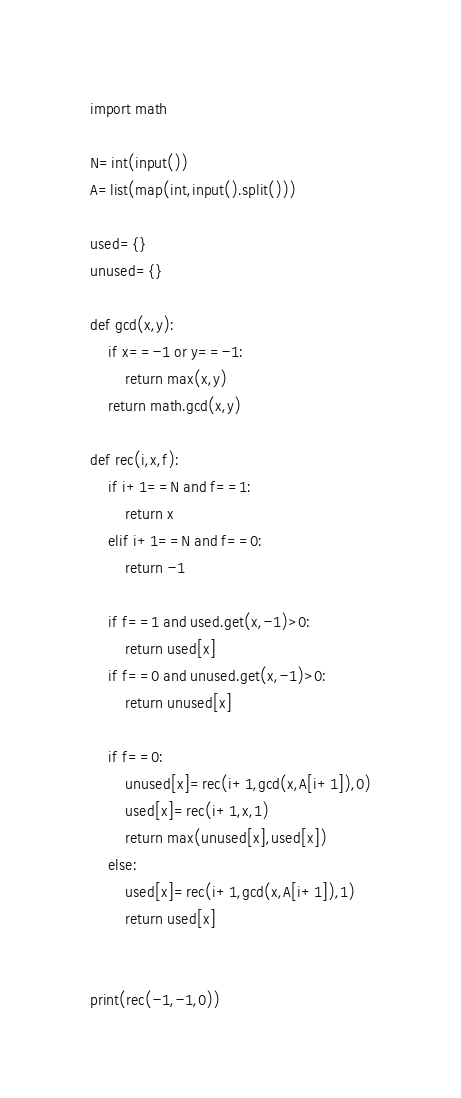<code> <loc_0><loc_0><loc_500><loc_500><_Python_>import math

N=int(input())
A=list(map(int,input().split()))

used={}
unused={}

def gcd(x,y):
    if x==-1 or y==-1:
        return max(x,y)
    return math.gcd(x,y)

def rec(i,x,f):
    if i+1==N and f==1:
        return x
    elif i+1==N and f==0:
        return -1
    
    if f==1 and used.get(x,-1)>0:
        return used[x]
    if f==0 and unused.get(x,-1)>0:
        return unused[x]
    
    if f==0:
        unused[x]=rec(i+1,gcd(x,A[i+1]),0)
        used[x]=rec(i+1,x,1)
        return max(unused[x],used[x])
    else:
        used[x]=rec(i+1,gcd(x,A[i+1]),1)
        return used[x]


print(rec(-1,-1,0))
</code> 